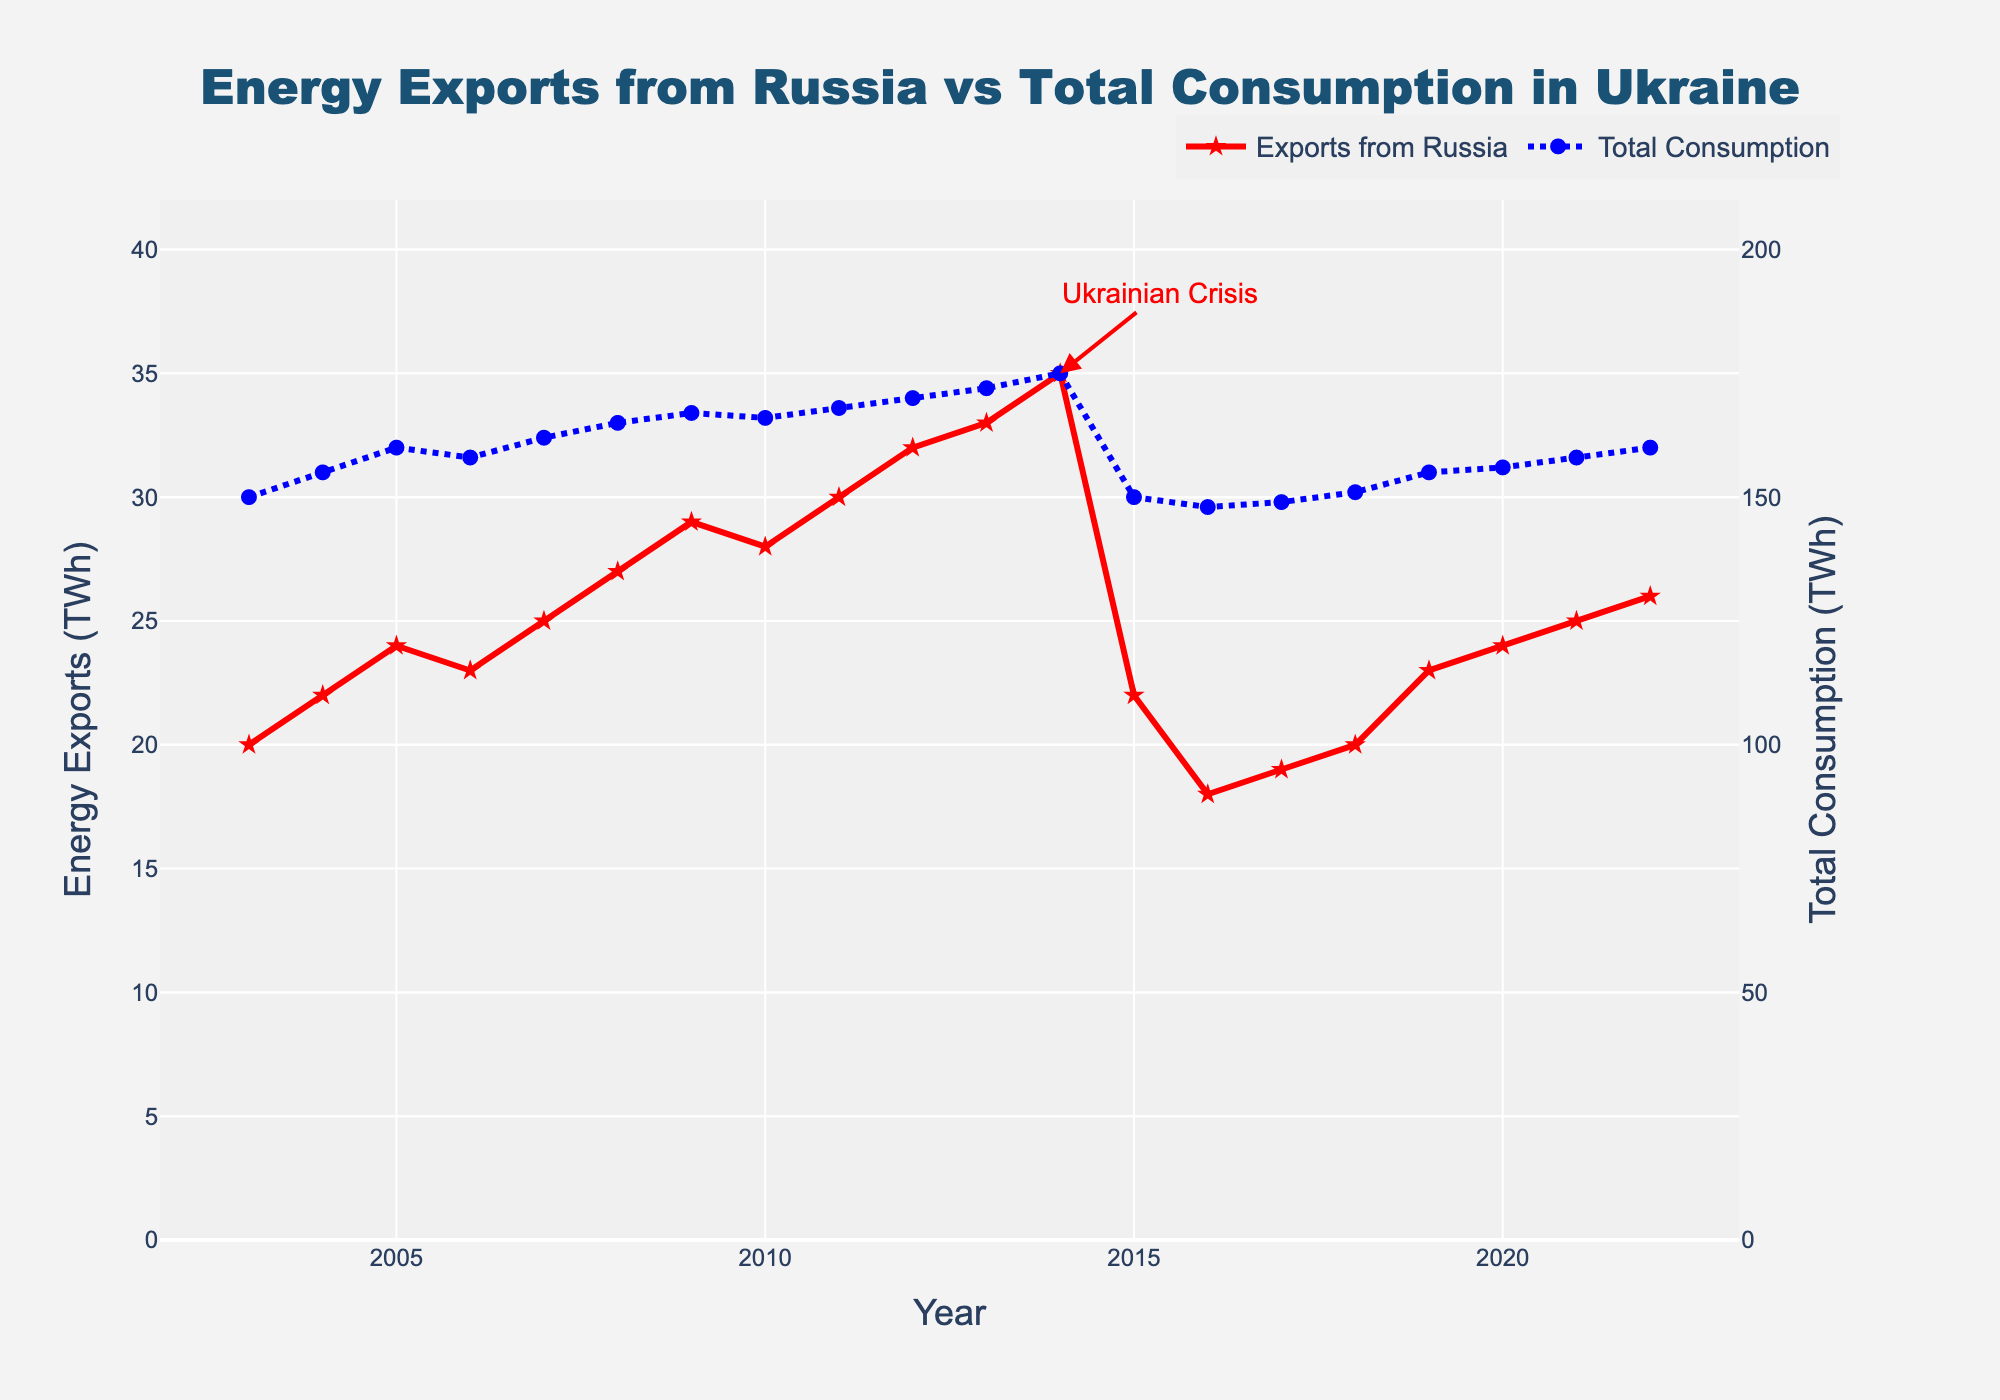What is the title of the figure? The title is usually located at the top of the figure and is often in larger and bold font. Here, the title reads "Energy Exports from Russia vs Total Consumption in Ukraine".
Answer: Energy Exports from Russia vs Total Consumption in Ukraine How many years are represented in the figure? By counting the number of distinct data points along the x-axis, we can see the years range from 2003 to 2022 inclusive. Each year has a corresponding data point for both variables.
Answer: 20 What annotation is included in the plot and at what year? The annotation usually highlights a significant event or point of interest. Here, there is an annotation "Ukrainian Crisis" at the year 2014.
Answer: Ukrainian Crisis at 2014 In what year did energy exports from Russia to Ukraine peak, and what was the value? To find the peak, look at the highest point on the red line representing "Exports from Russia". This peak occurs in 2014, with a value of 35 TWh.
Answer: 2014, 35 TWh How does the total energy consumption in Ukraine in 2022 compare to that in 2003? Compare the values at both ends of the blue line. In 2022, the total consumption is 160 TWh, while in 2003, it is 150 TWh.
Answer: 10 TWh higher in 2022 What was the trend in energy exports from Russia to Ukraine from 2013 to 2016? Examine the red line from 2013 to 2016. It peaks in 2014 and then shows a significant decline in 2015 and further drops in 2016.
Answer: Peaked in 2014, then declined By how much did the total energy consumption in Ukraine change from 2008 to 2009? Look at the blue line between 2008 and 2009. The consumption increased from 165 TWh in 2008 to 167 TWh in 2009. The change is 167 - 165 = 2 TWh.
Answer: 2 TWh increase Which year had the smallest value for energy exports from Russia and what was the value? Identify the lowest point on the red line. The smallest value occurred in 2016, with an export value of 18 TWh.
Answer: 2016, 18 TWh Calculate the average energy exports from Russia to Ukraine over the first five years (2003-2007). Add the export values from 2003 to 2007 (20, 22, 24, 23, 25) and then divide by 5. The sum is 114, so the average is 114 / 5.
Answer: 22.8 TWh 